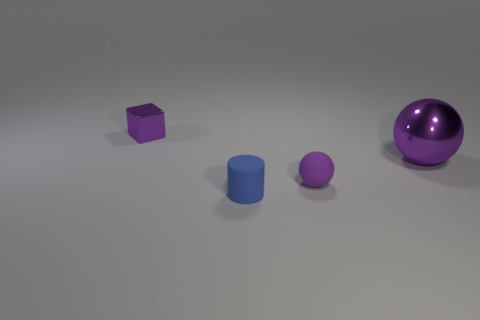Add 2 tiny gray metal objects. How many objects exist? 6 Subtract all cubes. How many objects are left? 3 Subtract 0 blue cubes. How many objects are left? 4 Subtract all rubber objects. Subtract all small blocks. How many objects are left? 1 Add 4 purple metallic spheres. How many purple metallic spheres are left? 5 Add 1 purple shiny spheres. How many purple shiny spheres exist? 2 